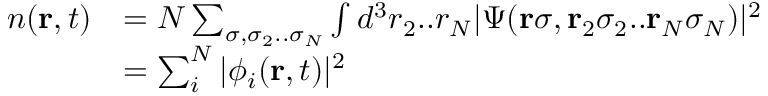<formula> <loc_0><loc_0><loc_500><loc_500>\begin{array} { r l } { n ( { r } , t ) } & { = N \sum _ { \sigma , \sigma _ { 2 } . . \sigma _ { N } } \int d ^ { 3 } r _ { 2 } . . r _ { N } | \Psi ( { r } \sigma , { r } _ { 2 } \sigma _ { 2 } . . { r } _ { N } \sigma _ { N } ) | ^ { 2 } } \\ & { = \sum _ { i } ^ { N } | \phi _ { i } ( { r } , t ) | ^ { 2 } } \end{array}</formula> 